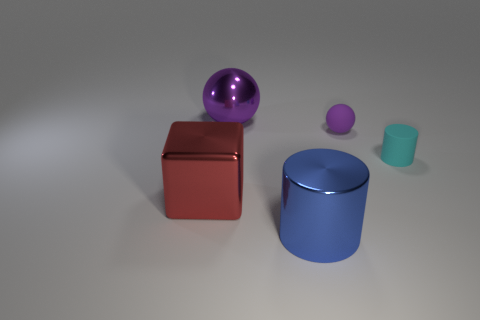Add 3 green things. How many objects exist? 8 Subtract all cubes. How many objects are left? 4 Subtract 0 blue spheres. How many objects are left? 5 Subtract all red cubes. Subtract all tiny purple things. How many objects are left? 3 Add 1 big red metallic objects. How many big red metallic objects are left? 2 Add 3 small purple rubber cylinders. How many small purple rubber cylinders exist? 3 